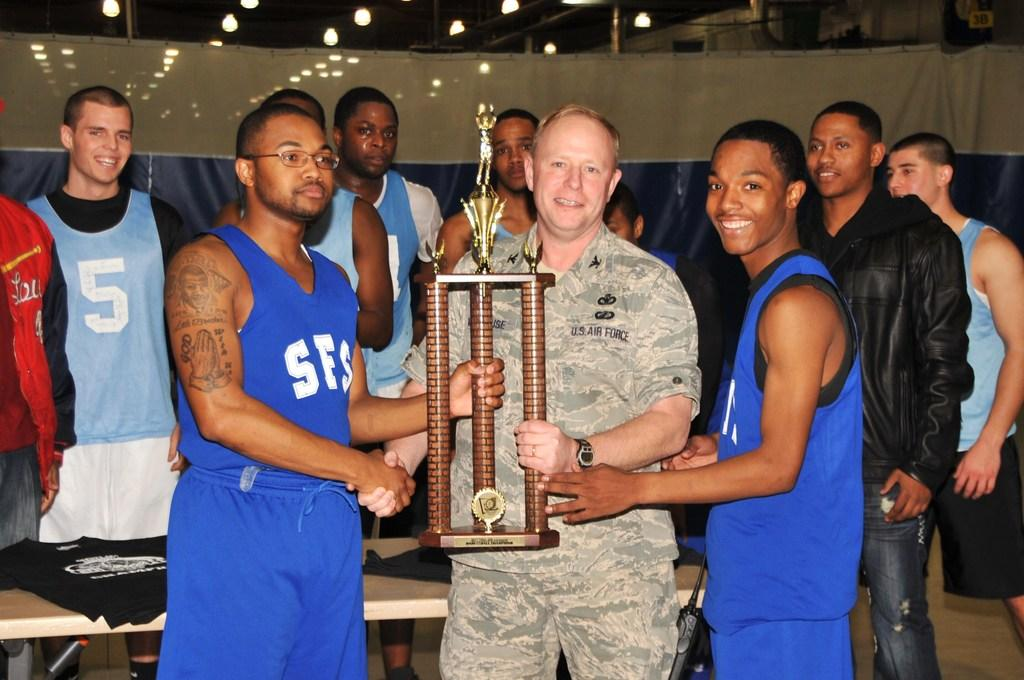Provide a one-sentence caption for the provided image. A United States Air Force Colonel and two basketball players holding a trophy. 